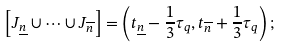Convert formula to latex. <formula><loc_0><loc_0><loc_500><loc_500>\left [ J _ { \underline { n } } \cup \dots \cup J _ { \overline { n } } \right ] = \left ( t _ { \underline { n } } - \frac { 1 } { 3 } \tau _ { q } , t _ { \overline { n } } + \frac { 1 } { 3 } \tau _ { q } \right ) ;</formula> 